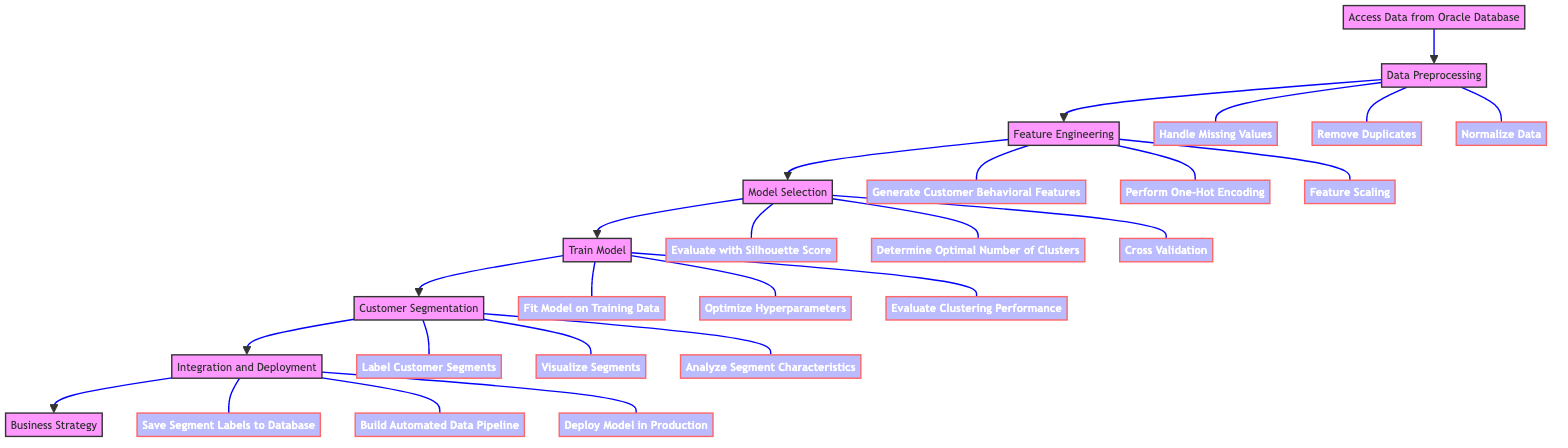What is the first step in the flow? The first step in the flow is "Access Data from Oracle Database", which is the starting point of the process.
Answer: Access Data from Oracle Database How many main process steps are there in the diagram? The diagram consists of seven main process steps, from accessing data to business strategy.
Answer: Seven What connection exists between 'Model Selection' and 'Train Model'? 'Model Selection' leads directly to 'Train Model', indicating that the selected models are trained afterwards.
Answer: Direct connection Which subtask involves handling data cleanliness? The subtasks "Handle Missing Values" and "Remove Duplicates" in 'Data Preprocessing' involve ensuring data cleanliness.
Answer: Handle Missing Values, Remove Duplicates What is the last step in the flow? The last step in the flow is "Business Strategy", which utilizes the insights gained from customer segmentation.
Answer: Business Strategy What is the purpose of the 'Integration and Deployment' step? The purpose of 'Integration and Deployment' is to save the segment labels to the database and prepare the model for production use.
Answer: Save Segment Labels to Database Which clustering algorithm types are evaluated in the 'Model Selection' stage? K-Means, DBSCAN, and Hierarchical Clustering are the clustering algorithm types evaluated during 'Model Selection'.
Answer: K-Means, DBSCAN, Hierarchical Clustering What is the main focus of 'Feature Engineering'? The main focus of 'Feature Engineering' is to generate relevant features to enhance machine learning model performance.
Answer: Generate relevant features What subtask is performed to visualize the customer segments? The subtask "Visualize Segments" is specifically performed in the 'Customer Segmentation' stage to visualize the outcomes.
Answer: Visualize Segments 